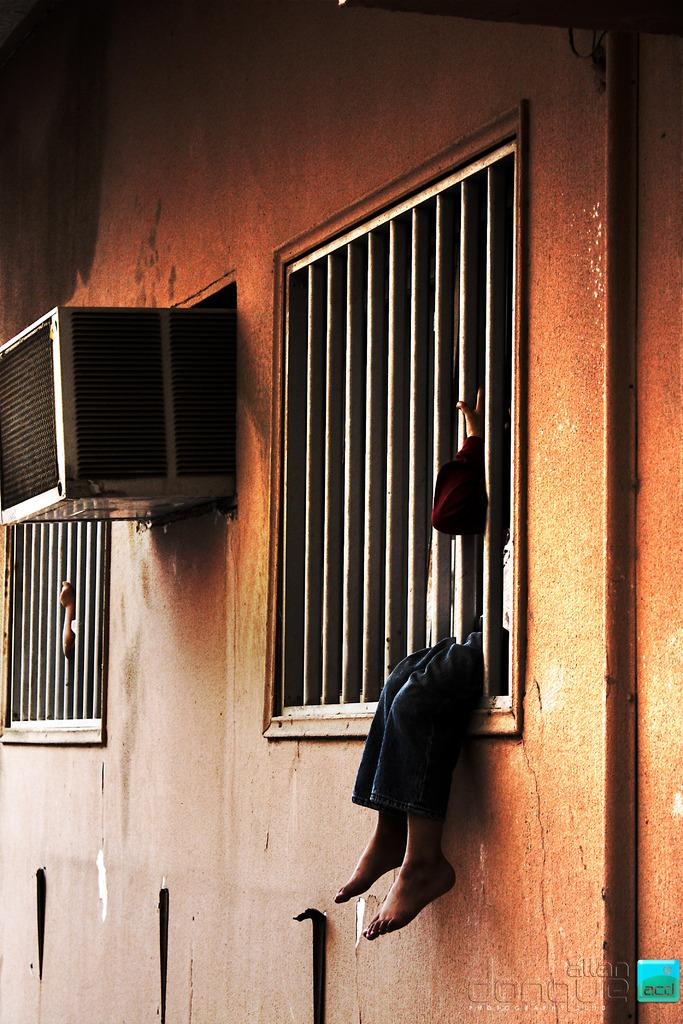What is a prominent feature in the image? There is a wall in the image. What color is the wall? The wall is brown in color. What is attached to the wall? An air conditioning unit (AC) is attached to the wall. Are there any openings in the wall? Yes, there are windows in the image. What is a person doing in relation to the windows? One person is sitting in a window. Can you see a trail of skate marks on the wall in the image? No, there are no skate marks visible on the wall in the image. 